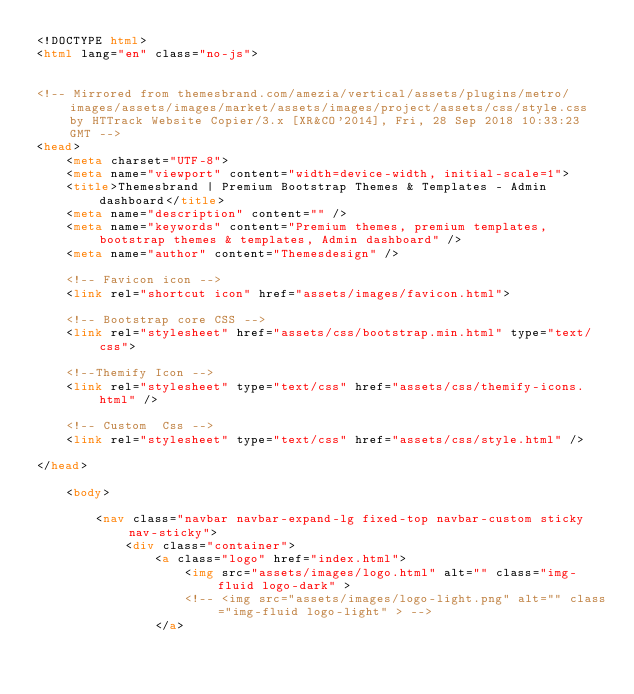<code> <loc_0><loc_0><loc_500><loc_500><_HTML_><!DOCTYPE html>
<html lang="en" class="no-js">


<!-- Mirrored from themesbrand.com/amezia/vertical/assets/plugins/metro/images/assets/images/market/assets/images/project/assets/css/style.css by HTTrack Website Copier/3.x [XR&CO'2014], Fri, 28 Sep 2018 10:33:23 GMT -->
<head>
    <meta charset="UTF-8">
    <meta name="viewport" content="width=device-width, initial-scale=1">
    <title>Themesbrand | Premium Bootstrap Themes & Templates - Admin dashboard</title>
    <meta name="description" content="" />
    <meta name="keywords" content="Premium themes, premium templates, bootstrap themes & templates, Admin dashboard" />
    <meta name="author" content="Themesdesign" />

    <!-- Favicon icon -->
    <link rel="shortcut icon" href="assets/images/favicon.html">

    <!-- Bootstrap core CSS -->
    <link rel="stylesheet" href="assets/css/bootstrap.min.html" type="text/css">

    <!--Themify Icon -->
    <link rel="stylesheet" type="text/css" href="assets/css/themify-icons.html" />

    <!-- Custom  Css -->
    <link rel="stylesheet" type="text/css" href="assets/css/style.html" />

</head>

    <body>

        <nav class="navbar navbar-expand-lg fixed-top navbar-custom sticky nav-sticky">
            <div class="container">
                <a class="logo" href="index.html">
                    <img src="assets/images/logo.html" alt="" class="img-fluid logo-dark" >
                    <!-- <img src="assets/images/logo-light.png" alt="" class="img-fluid logo-light" > -->
                </a></code> 